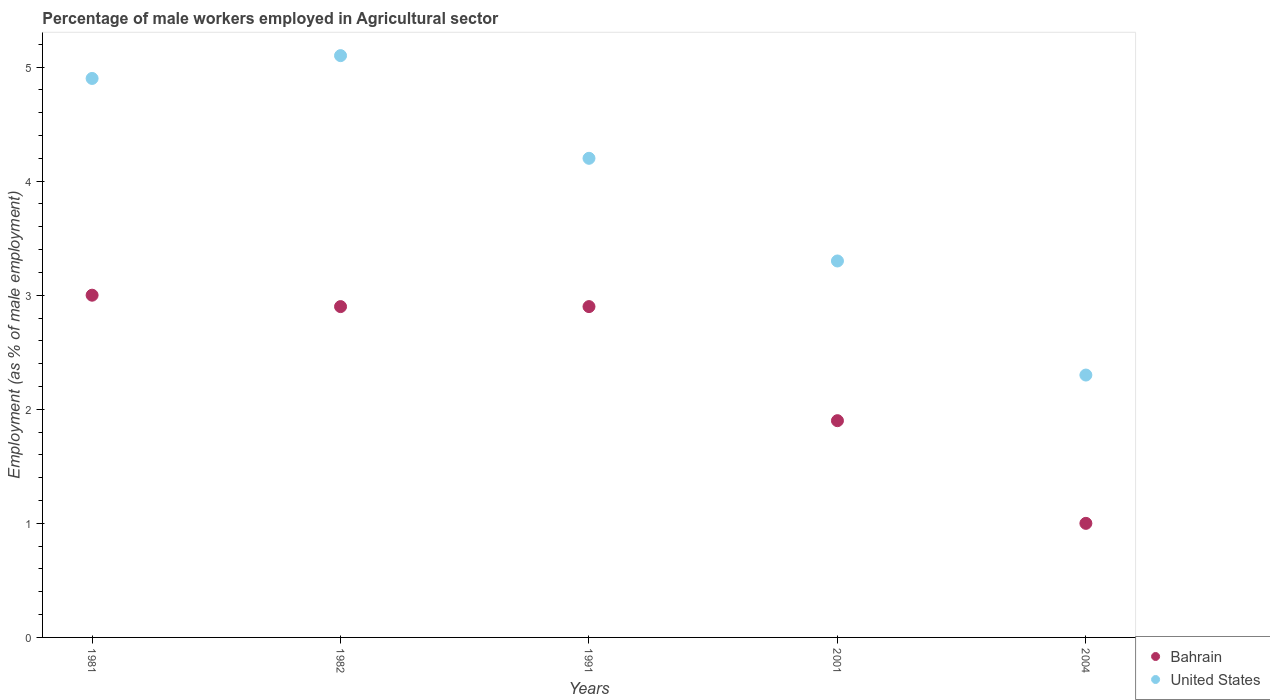How many different coloured dotlines are there?
Your response must be concise. 2. Is the number of dotlines equal to the number of legend labels?
Keep it short and to the point. Yes. What is the percentage of male workers employed in Agricultural sector in United States in 1982?
Make the answer very short. 5.1. Across all years, what is the maximum percentage of male workers employed in Agricultural sector in Bahrain?
Provide a short and direct response. 3. In which year was the percentage of male workers employed in Agricultural sector in United States maximum?
Offer a terse response. 1982. What is the total percentage of male workers employed in Agricultural sector in United States in the graph?
Offer a very short reply. 19.8. What is the difference between the percentage of male workers employed in Agricultural sector in Bahrain in 1991 and that in 2004?
Ensure brevity in your answer.  1.9. What is the difference between the percentage of male workers employed in Agricultural sector in Bahrain in 1981 and the percentage of male workers employed in Agricultural sector in United States in 1982?
Keep it short and to the point. -2.1. What is the average percentage of male workers employed in Agricultural sector in Bahrain per year?
Provide a succinct answer. 2.34. In the year 2004, what is the difference between the percentage of male workers employed in Agricultural sector in Bahrain and percentage of male workers employed in Agricultural sector in United States?
Keep it short and to the point. -1.3. In how many years, is the percentage of male workers employed in Agricultural sector in Bahrain greater than 0.6000000000000001 %?
Provide a short and direct response. 5. What is the ratio of the percentage of male workers employed in Agricultural sector in United States in 1991 to that in 2001?
Provide a short and direct response. 1.27. What is the difference between the highest and the second highest percentage of male workers employed in Agricultural sector in Bahrain?
Provide a succinct answer. 0.1. What is the difference between the highest and the lowest percentage of male workers employed in Agricultural sector in United States?
Offer a very short reply. 2.8. In how many years, is the percentage of male workers employed in Agricultural sector in Bahrain greater than the average percentage of male workers employed in Agricultural sector in Bahrain taken over all years?
Your response must be concise. 3. Is the sum of the percentage of male workers employed in Agricultural sector in United States in 1991 and 2004 greater than the maximum percentage of male workers employed in Agricultural sector in Bahrain across all years?
Ensure brevity in your answer.  Yes. Is the percentage of male workers employed in Agricultural sector in Bahrain strictly greater than the percentage of male workers employed in Agricultural sector in United States over the years?
Offer a very short reply. No. Is the percentage of male workers employed in Agricultural sector in Bahrain strictly less than the percentage of male workers employed in Agricultural sector in United States over the years?
Your answer should be very brief. Yes. How many dotlines are there?
Provide a short and direct response. 2. How many years are there in the graph?
Give a very brief answer. 5. Does the graph contain any zero values?
Make the answer very short. No. Does the graph contain grids?
Your response must be concise. No. Where does the legend appear in the graph?
Your answer should be very brief. Bottom right. What is the title of the graph?
Ensure brevity in your answer.  Percentage of male workers employed in Agricultural sector. What is the label or title of the Y-axis?
Offer a very short reply. Employment (as % of male employment). What is the Employment (as % of male employment) in United States in 1981?
Make the answer very short. 4.9. What is the Employment (as % of male employment) of Bahrain in 1982?
Your answer should be very brief. 2.9. What is the Employment (as % of male employment) of United States in 1982?
Provide a succinct answer. 5.1. What is the Employment (as % of male employment) of Bahrain in 1991?
Make the answer very short. 2.9. What is the Employment (as % of male employment) in United States in 1991?
Your answer should be compact. 4.2. What is the Employment (as % of male employment) in Bahrain in 2001?
Your response must be concise. 1.9. What is the Employment (as % of male employment) in United States in 2001?
Your response must be concise. 3.3. What is the Employment (as % of male employment) in United States in 2004?
Make the answer very short. 2.3. Across all years, what is the maximum Employment (as % of male employment) of United States?
Keep it short and to the point. 5.1. Across all years, what is the minimum Employment (as % of male employment) in Bahrain?
Give a very brief answer. 1. Across all years, what is the minimum Employment (as % of male employment) of United States?
Provide a short and direct response. 2.3. What is the total Employment (as % of male employment) in Bahrain in the graph?
Offer a very short reply. 11.7. What is the total Employment (as % of male employment) of United States in the graph?
Make the answer very short. 19.8. What is the difference between the Employment (as % of male employment) in Bahrain in 1981 and that in 1982?
Your answer should be very brief. 0.1. What is the difference between the Employment (as % of male employment) in Bahrain in 1981 and that in 1991?
Offer a terse response. 0.1. What is the difference between the Employment (as % of male employment) in United States in 1981 and that in 1991?
Your response must be concise. 0.7. What is the difference between the Employment (as % of male employment) of Bahrain in 1981 and that in 2001?
Make the answer very short. 1.1. What is the difference between the Employment (as % of male employment) in United States in 1982 and that in 2004?
Keep it short and to the point. 2.8. What is the difference between the Employment (as % of male employment) in Bahrain in 1991 and that in 2001?
Your response must be concise. 1. What is the difference between the Employment (as % of male employment) of Bahrain in 2001 and that in 2004?
Your answer should be compact. 0.9. What is the difference between the Employment (as % of male employment) of Bahrain in 1981 and the Employment (as % of male employment) of United States in 1982?
Your answer should be compact. -2.1. What is the difference between the Employment (as % of male employment) in Bahrain in 1981 and the Employment (as % of male employment) in United States in 1991?
Your answer should be very brief. -1.2. What is the difference between the Employment (as % of male employment) of Bahrain in 1982 and the Employment (as % of male employment) of United States in 2001?
Provide a succinct answer. -0.4. What is the difference between the Employment (as % of male employment) of Bahrain in 1991 and the Employment (as % of male employment) of United States in 2001?
Provide a short and direct response. -0.4. What is the difference between the Employment (as % of male employment) of Bahrain in 1991 and the Employment (as % of male employment) of United States in 2004?
Your answer should be compact. 0.6. What is the difference between the Employment (as % of male employment) of Bahrain in 2001 and the Employment (as % of male employment) of United States in 2004?
Offer a very short reply. -0.4. What is the average Employment (as % of male employment) in Bahrain per year?
Keep it short and to the point. 2.34. What is the average Employment (as % of male employment) in United States per year?
Make the answer very short. 3.96. In the year 1981, what is the difference between the Employment (as % of male employment) of Bahrain and Employment (as % of male employment) of United States?
Your response must be concise. -1.9. In the year 1991, what is the difference between the Employment (as % of male employment) of Bahrain and Employment (as % of male employment) of United States?
Provide a short and direct response. -1.3. In the year 2001, what is the difference between the Employment (as % of male employment) in Bahrain and Employment (as % of male employment) in United States?
Make the answer very short. -1.4. What is the ratio of the Employment (as % of male employment) in Bahrain in 1981 to that in 1982?
Your answer should be compact. 1.03. What is the ratio of the Employment (as % of male employment) in United States in 1981 to that in 1982?
Offer a terse response. 0.96. What is the ratio of the Employment (as % of male employment) of Bahrain in 1981 to that in 1991?
Provide a succinct answer. 1.03. What is the ratio of the Employment (as % of male employment) of Bahrain in 1981 to that in 2001?
Provide a short and direct response. 1.58. What is the ratio of the Employment (as % of male employment) of United States in 1981 to that in 2001?
Your response must be concise. 1.48. What is the ratio of the Employment (as % of male employment) of Bahrain in 1981 to that in 2004?
Offer a very short reply. 3. What is the ratio of the Employment (as % of male employment) in United States in 1981 to that in 2004?
Make the answer very short. 2.13. What is the ratio of the Employment (as % of male employment) in United States in 1982 to that in 1991?
Give a very brief answer. 1.21. What is the ratio of the Employment (as % of male employment) of Bahrain in 1982 to that in 2001?
Offer a terse response. 1.53. What is the ratio of the Employment (as % of male employment) of United States in 1982 to that in 2001?
Your answer should be very brief. 1.55. What is the ratio of the Employment (as % of male employment) in Bahrain in 1982 to that in 2004?
Provide a short and direct response. 2.9. What is the ratio of the Employment (as % of male employment) of United States in 1982 to that in 2004?
Keep it short and to the point. 2.22. What is the ratio of the Employment (as % of male employment) in Bahrain in 1991 to that in 2001?
Provide a succinct answer. 1.53. What is the ratio of the Employment (as % of male employment) in United States in 1991 to that in 2001?
Your answer should be very brief. 1.27. What is the ratio of the Employment (as % of male employment) of United States in 1991 to that in 2004?
Your answer should be very brief. 1.83. What is the ratio of the Employment (as % of male employment) in United States in 2001 to that in 2004?
Offer a very short reply. 1.43. What is the difference between the highest and the second highest Employment (as % of male employment) of Bahrain?
Keep it short and to the point. 0.1. What is the difference between the highest and the second highest Employment (as % of male employment) in United States?
Give a very brief answer. 0.2. What is the difference between the highest and the lowest Employment (as % of male employment) of Bahrain?
Ensure brevity in your answer.  2. 